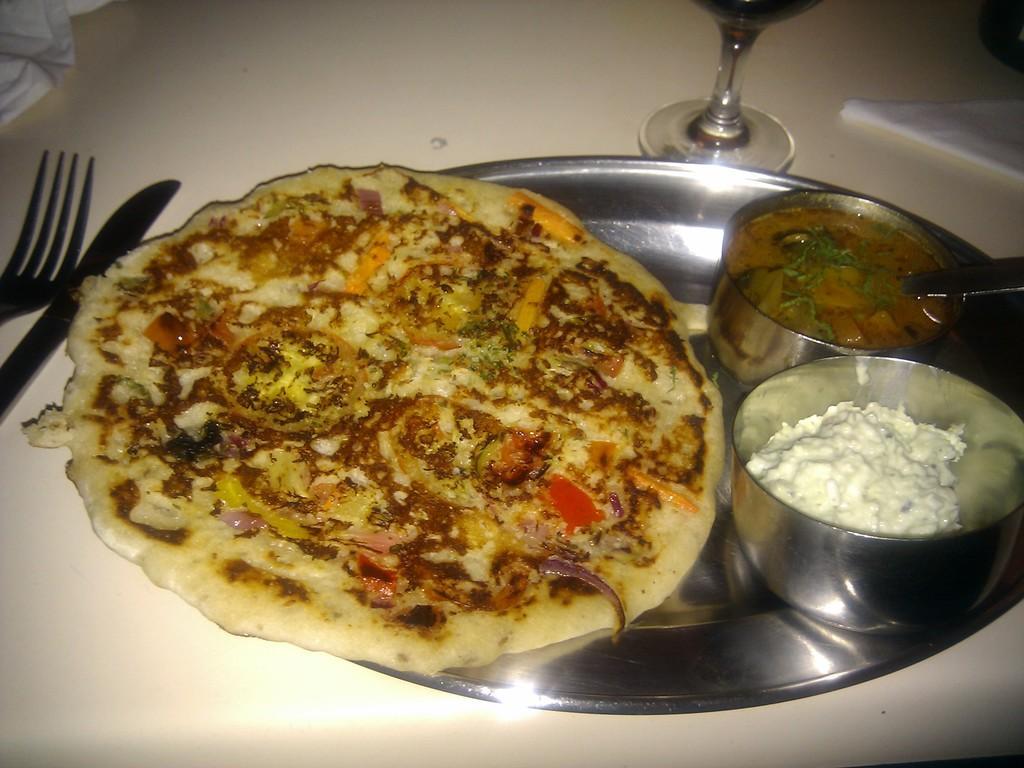Can you describe this image briefly? In the image there is a roti on the plate with curry in two bowls and beside it there is wine glass,knife and fork on the table. 